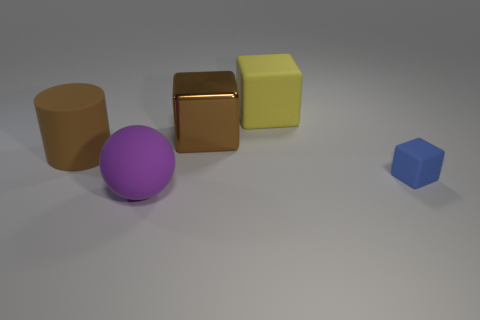Are there more objects that are in front of the tiny blue object than big brown things?
Provide a succinct answer. No. There is a brown thing that is in front of the brown object to the right of the big brown cylinder; what number of large rubber cylinders are on the right side of it?
Your answer should be very brief. 0. Does the brown object on the left side of the rubber sphere have the same shape as the small rubber thing?
Your response must be concise. No. There is a thing to the left of the large purple object; what is it made of?
Offer a very short reply. Rubber. What is the shape of the thing that is both in front of the large matte cylinder and to the left of the big yellow cube?
Provide a short and direct response. Sphere. What material is the tiny block?
Keep it short and to the point. Rubber. What number of cylinders are big cyan metallic objects or big objects?
Offer a terse response. 1. Does the purple sphere have the same material as the brown cylinder?
Give a very brief answer. Yes. What size is the brown shiny thing that is the same shape as the yellow object?
Offer a terse response. Large. There is a block that is both right of the big shiny cube and behind the blue cube; what is its material?
Keep it short and to the point. Rubber. 